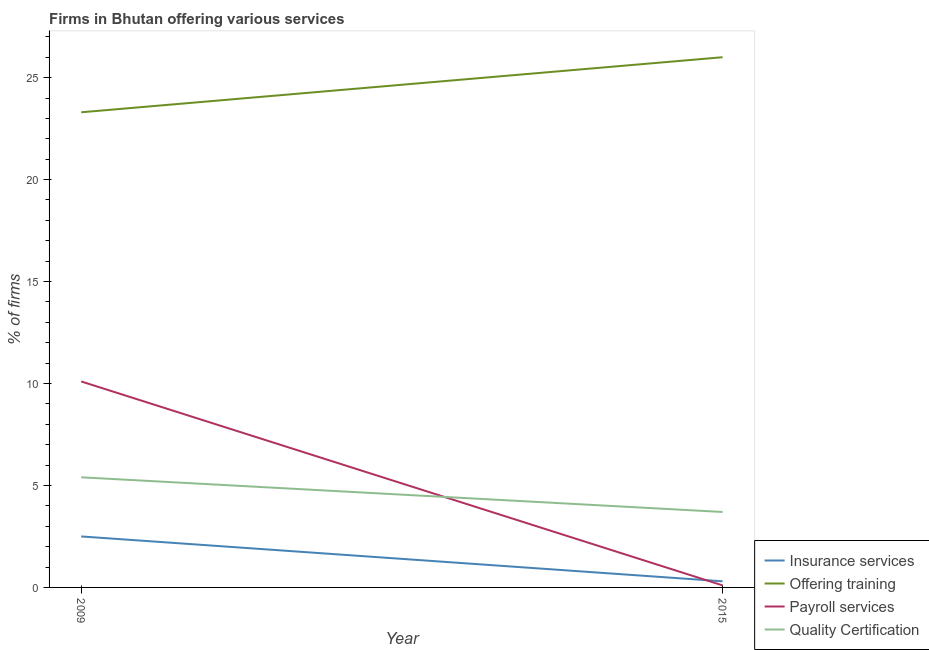How many different coloured lines are there?
Offer a very short reply. 4. Does the line corresponding to percentage of firms offering payroll services intersect with the line corresponding to percentage of firms offering training?
Give a very brief answer. No. What is the percentage of firms offering training in 2015?
Offer a very short reply. 26. Across all years, what is the maximum percentage of firms offering training?
Offer a terse response. 26. Across all years, what is the minimum percentage of firms offering insurance services?
Offer a terse response. 0.3. In which year was the percentage of firms offering training maximum?
Your answer should be compact. 2015. What is the difference between the percentage of firms offering training in 2009 and that in 2015?
Offer a terse response. -2.7. What is the average percentage of firms offering training per year?
Your answer should be very brief. 24.65. In how many years, is the percentage of firms offering insurance services greater than 1 %?
Give a very brief answer. 1. What is the ratio of the percentage of firms offering quality certification in 2009 to that in 2015?
Give a very brief answer. 1.46. Is the percentage of firms offering training in 2009 less than that in 2015?
Make the answer very short. Yes. Is it the case that in every year, the sum of the percentage of firms offering training and percentage of firms offering payroll services is greater than the sum of percentage of firms offering quality certification and percentage of firms offering insurance services?
Give a very brief answer. No. Is it the case that in every year, the sum of the percentage of firms offering insurance services and percentage of firms offering training is greater than the percentage of firms offering payroll services?
Offer a terse response. Yes. How many lines are there?
Provide a short and direct response. 4. How many years are there in the graph?
Provide a short and direct response. 2. Are the values on the major ticks of Y-axis written in scientific E-notation?
Offer a very short reply. No. Does the graph contain grids?
Your response must be concise. No. Where does the legend appear in the graph?
Keep it short and to the point. Bottom right. How are the legend labels stacked?
Offer a terse response. Vertical. What is the title of the graph?
Ensure brevity in your answer.  Firms in Bhutan offering various services . What is the label or title of the X-axis?
Give a very brief answer. Year. What is the label or title of the Y-axis?
Your answer should be compact. % of firms. What is the % of firms of Insurance services in 2009?
Offer a terse response. 2.5. What is the % of firms of Offering training in 2009?
Give a very brief answer. 23.3. What is the % of firms of Insurance services in 2015?
Make the answer very short. 0.3. What is the % of firms in Payroll services in 2015?
Offer a very short reply. 0.1. What is the % of firms of Quality Certification in 2015?
Provide a succinct answer. 3.7. Across all years, what is the minimum % of firms of Insurance services?
Your answer should be compact. 0.3. Across all years, what is the minimum % of firms in Offering training?
Make the answer very short. 23.3. Across all years, what is the minimum % of firms in Payroll services?
Your response must be concise. 0.1. Across all years, what is the minimum % of firms in Quality Certification?
Give a very brief answer. 3.7. What is the total % of firms in Insurance services in the graph?
Your answer should be compact. 2.8. What is the total % of firms of Offering training in the graph?
Offer a terse response. 49.3. What is the total % of firms in Payroll services in the graph?
Your answer should be very brief. 10.2. What is the difference between the % of firms of Insurance services in 2009 and that in 2015?
Give a very brief answer. 2.2. What is the difference between the % of firms in Offering training in 2009 and that in 2015?
Your answer should be very brief. -2.7. What is the difference between the % of firms in Insurance services in 2009 and the % of firms in Offering training in 2015?
Provide a short and direct response. -23.5. What is the difference between the % of firms of Offering training in 2009 and the % of firms of Payroll services in 2015?
Your answer should be compact. 23.2. What is the difference between the % of firms in Offering training in 2009 and the % of firms in Quality Certification in 2015?
Provide a succinct answer. 19.6. What is the average % of firms in Offering training per year?
Your answer should be very brief. 24.65. What is the average % of firms of Quality Certification per year?
Keep it short and to the point. 4.55. In the year 2009, what is the difference between the % of firms of Insurance services and % of firms of Offering training?
Offer a terse response. -20.8. In the year 2009, what is the difference between the % of firms of Insurance services and % of firms of Payroll services?
Your response must be concise. -7.6. In the year 2009, what is the difference between the % of firms in Offering training and % of firms in Payroll services?
Offer a very short reply. 13.2. In the year 2009, what is the difference between the % of firms of Payroll services and % of firms of Quality Certification?
Offer a very short reply. 4.7. In the year 2015, what is the difference between the % of firms of Insurance services and % of firms of Offering training?
Your answer should be very brief. -25.7. In the year 2015, what is the difference between the % of firms of Insurance services and % of firms of Payroll services?
Give a very brief answer. 0.2. In the year 2015, what is the difference between the % of firms of Offering training and % of firms of Payroll services?
Offer a terse response. 25.9. In the year 2015, what is the difference between the % of firms of Offering training and % of firms of Quality Certification?
Provide a succinct answer. 22.3. What is the ratio of the % of firms in Insurance services in 2009 to that in 2015?
Ensure brevity in your answer.  8.33. What is the ratio of the % of firms in Offering training in 2009 to that in 2015?
Keep it short and to the point. 0.9. What is the ratio of the % of firms in Payroll services in 2009 to that in 2015?
Make the answer very short. 101. What is the ratio of the % of firms in Quality Certification in 2009 to that in 2015?
Keep it short and to the point. 1.46. What is the difference between the highest and the second highest % of firms of Offering training?
Offer a very short reply. 2.7. What is the difference between the highest and the second highest % of firms of Payroll services?
Provide a succinct answer. 10. What is the difference between the highest and the lowest % of firms of Insurance services?
Ensure brevity in your answer.  2.2. What is the difference between the highest and the lowest % of firms in Quality Certification?
Provide a succinct answer. 1.7. 